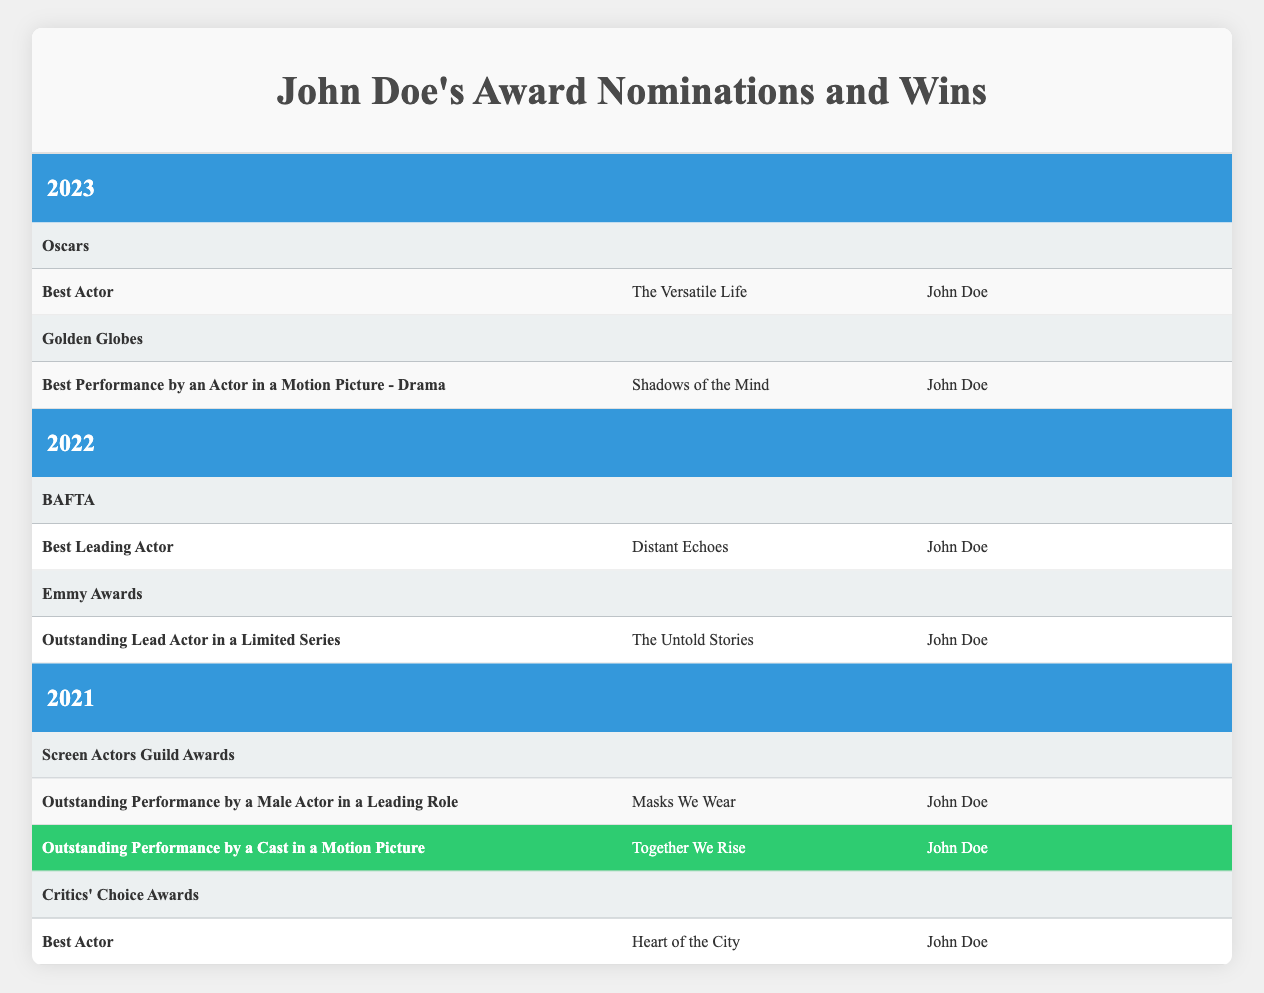What awards did John Doe receive nominations for in 2023? In 2023, John Doe received nominations for two awards: the Oscars in the Best Actor category for the film "The Versatile Life" and the Golden Globes in the Best Performance by an Actor in a Motion Picture - Drama category for the film "Shadows of the Mind."
Answer: Oscars, Golden Globes Did John Doe win any awards in 2022? According to the table, there are no wins listed for John Doe in 2022 under both the BAFTA and Emmy Awards categories.
Answer: No What was the category of the award for which John Doe won in 2021? In 2021, John Doe won under the category of Outstanding Performance by a Cast in a Motion Picture for the film "Together We Rise."
Answer: Outstanding Performance by a Cast in a Motion Picture How many nominations did John Doe receive across all awards in 2021? In 2021, John Doe received two nominations: one for the Screen Actors Guild Awards and one for the Critics' Choice Awards. Therefore, the total is two nominations.
Answer: 2 In which year did John Doe have the most award nominations? By analyzing the years in the table, John Doe received nominations in both 2021 (2 nominations) and 2023 (2 nominations), but fewer in 2022 (2). Since the data shows no overlapping for extra nominations, the highest are in both 2021 and 2023 as they are equal.
Answer: 2021 and 2023 What was the film associated with the Best Leading Actor nomination in 2022? The Best Leading Actor nomination in 2022 at the BAFTA was for the film "Distant Echoes," where John Doe was nominated.
Answer: Distant Echoes Did John Doe receive a nomination for an Emmy Award in 2022? Yes, the table indicates that John Doe received a nomination for Outstanding Lead Actor in a Limited Series at the Emmy Awards in 2022.
Answer: Yes How many total wins did John Doe have from 2021 to 2023? From 2021 to 2023, John Doe had one win listed under the Screen Actors Guild Awards in 2021 and no wins in the subsequent years. Therefore, total wins are one.
Answer: 1 